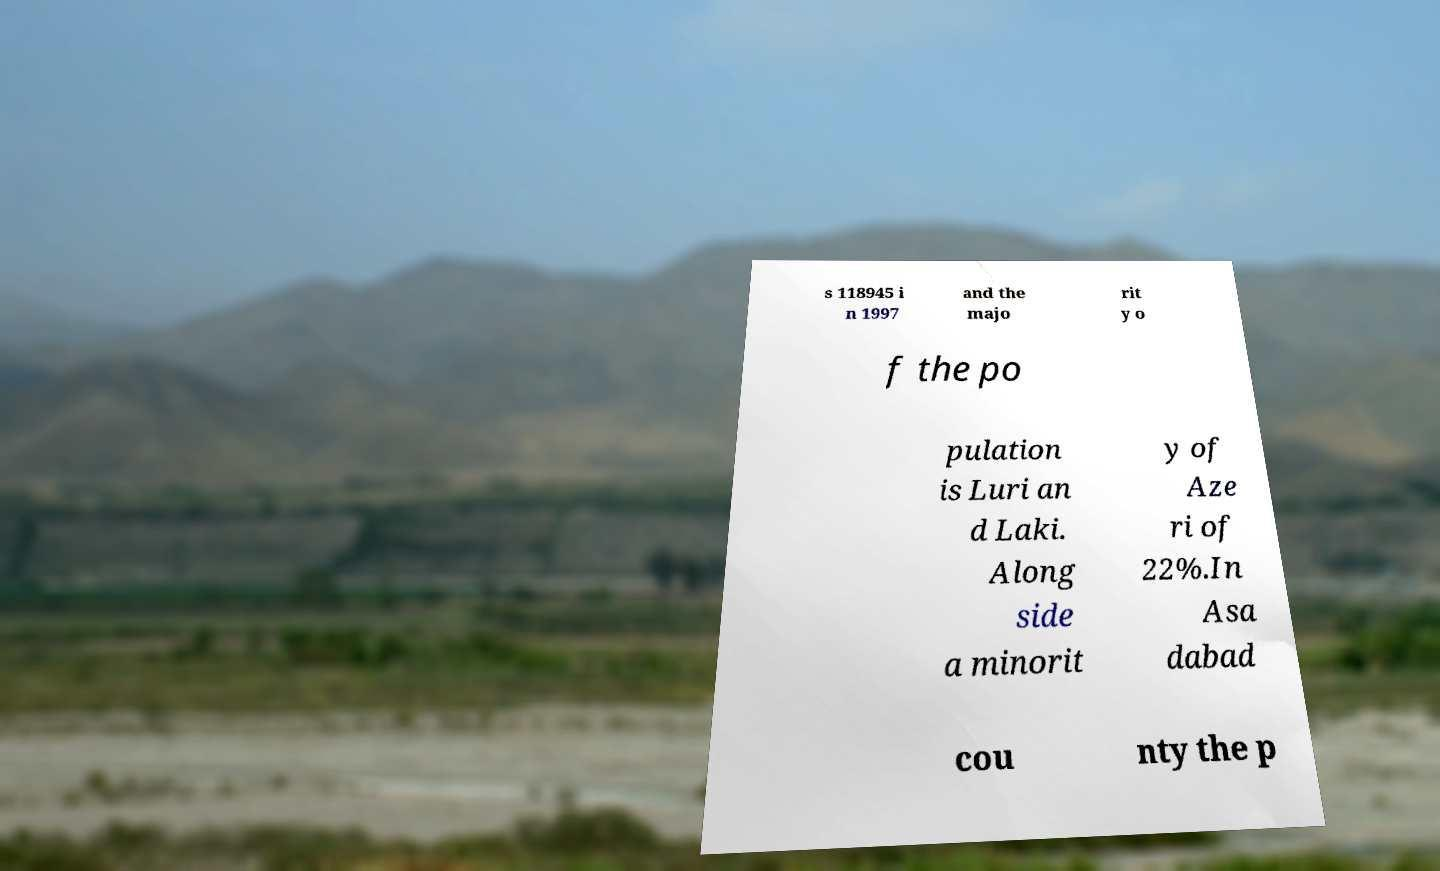Could you extract and type out the text from this image? s 118945 i n 1997 and the majo rit y o f the po pulation is Luri an d Laki. Along side a minorit y of Aze ri of 22%.In Asa dabad cou nty the p 